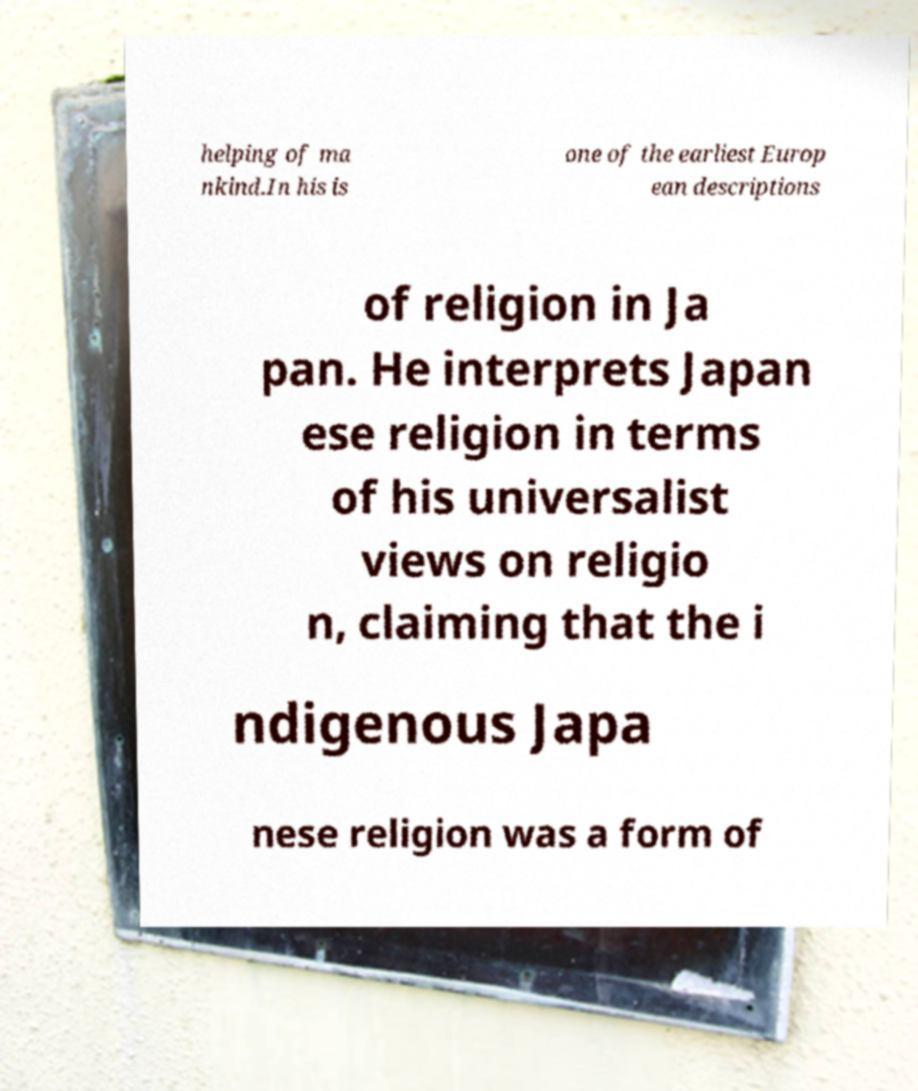Can you accurately transcribe the text from the provided image for me? helping of ma nkind.In his is one of the earliest Europ ean descriptions of religion in Ja pan. He interprets Japan ese religion in terms of his universalist views on religio n, claiming that the i ndigenous Japa nese religion was a form of 